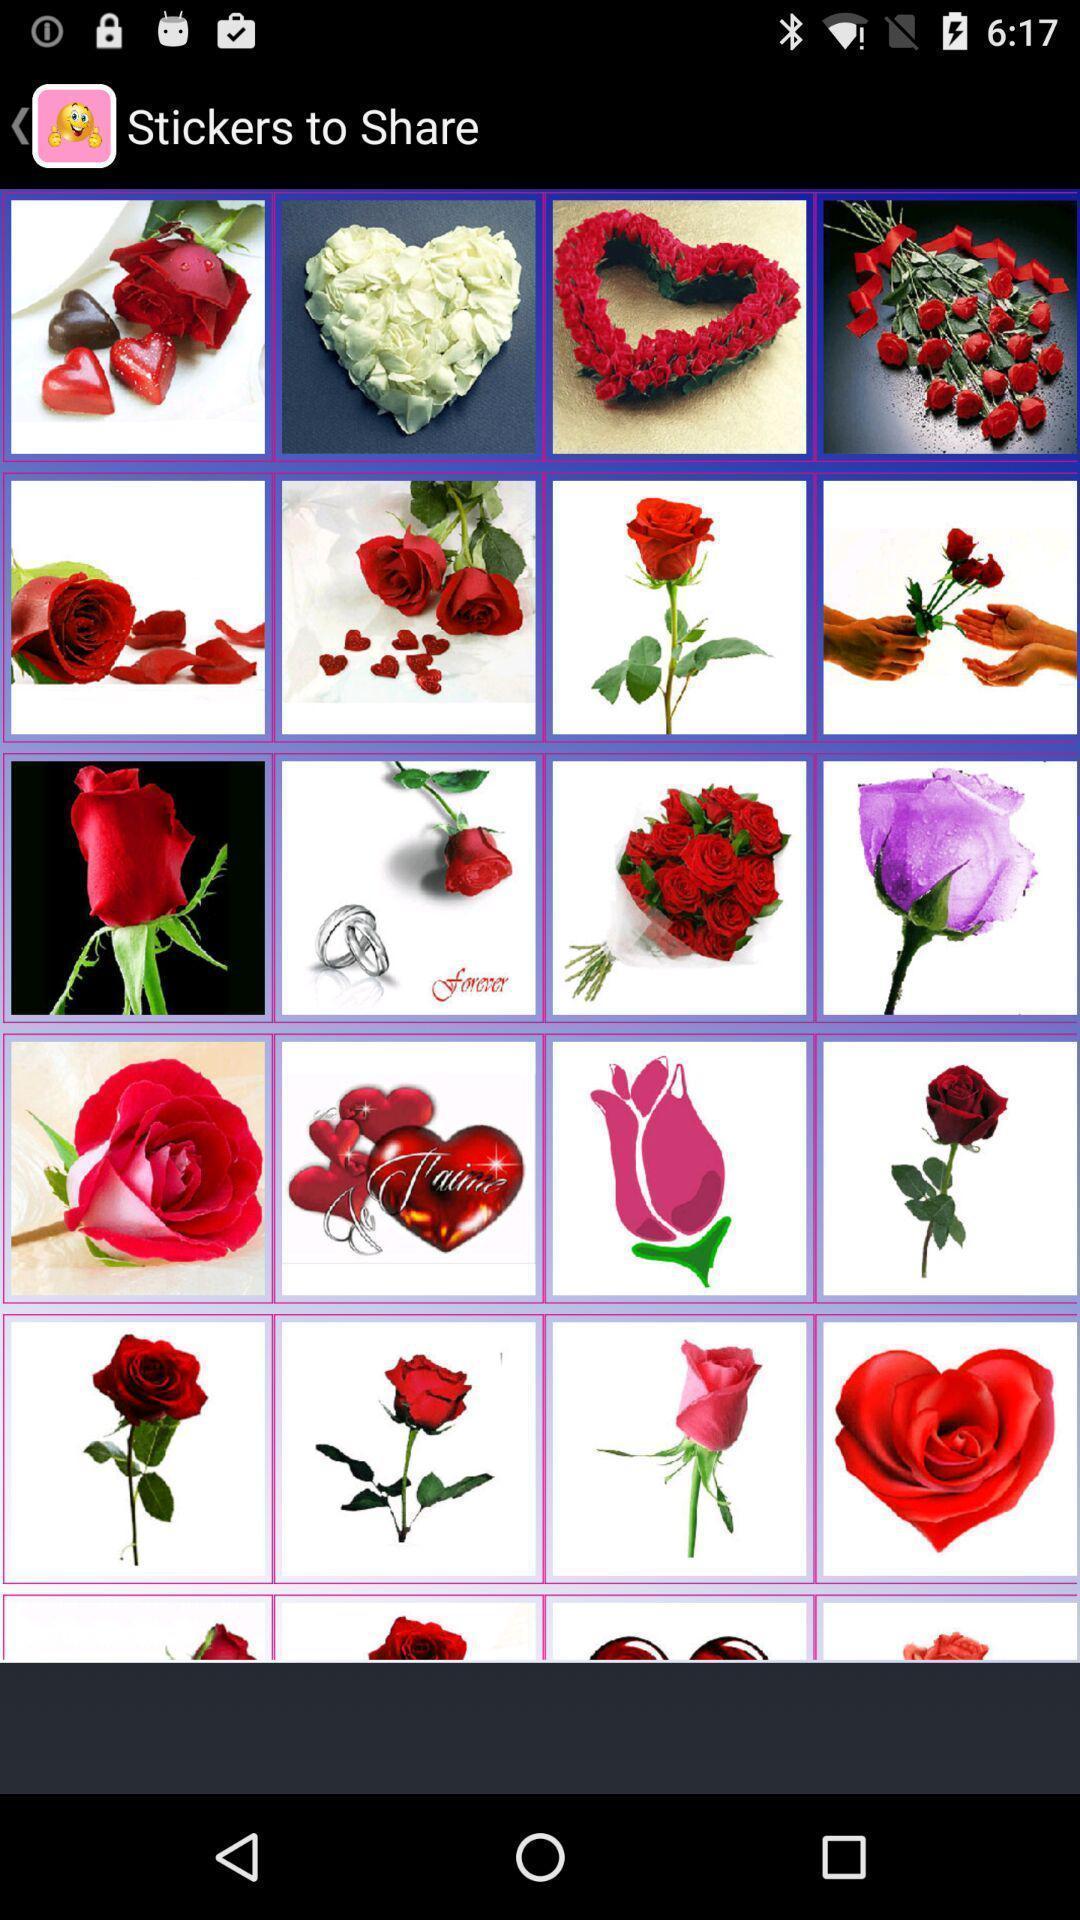What is the overall content of this screenshot? Screen displaying multiple stickers to share. 